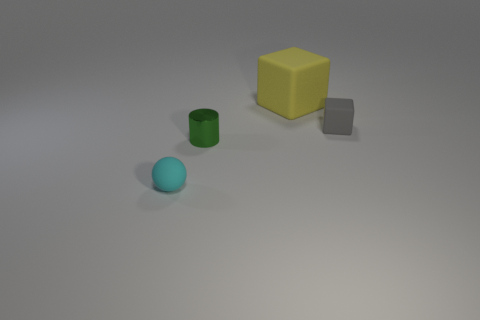Add 4 green shiny things. How many objects exist? 8 Subtract all big shiny cylinders. Subtract all tiny rubber things. How many objects are left? 2 Add 2 small rubber balls. How many small rubber balls are left? 3 Add 1 large cyan rubber objects. How many large cyan rubber objects exist? 1 Subtract 0 gray cylinders. How many objects are left? 4 